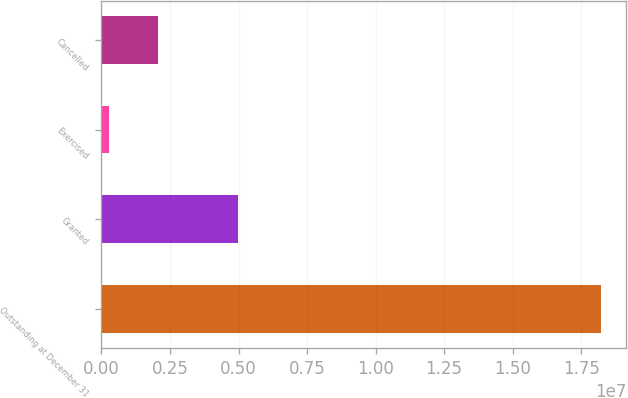Convert chart. <chart><loc_0><loc_0><loc_500><loc_500><bar_chart><fcel>Outstanding at December 31<fcel>Granted<fcel>Exercised<fcel>Cancelled<nl><fcel>1.82301e+07<fcel>4.9705e+06<fcel>273382<fcel>2.06905e+06<nl></chart> 